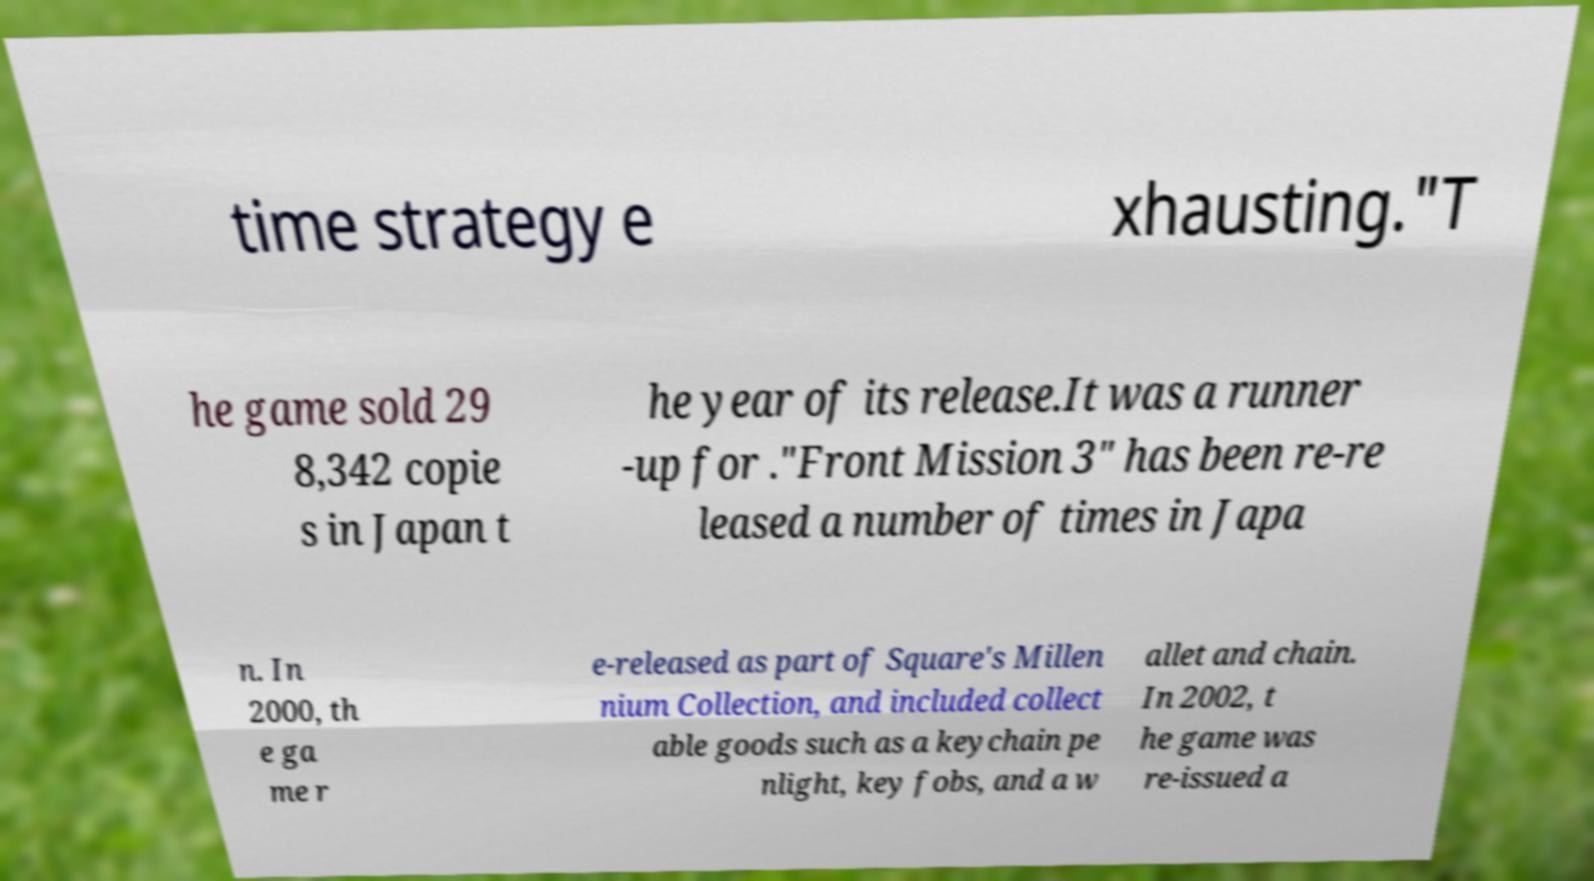Could you assist in decoding the text presented in this image and type it out clearly? time strategy e xhausting."T he game sold 29 8,342 copie s in Japan t he year of its release.It was a runner -up for ."Front Mission 3" has been re-re leased a number of times in Japa n. In 2000, th e ga me r e-released as part of Square's Millen nium Collection, and included collect able goods such as a keychain pe nlight, key fobs, and a w allet and chain. In 2002, t he game was re-issued a 